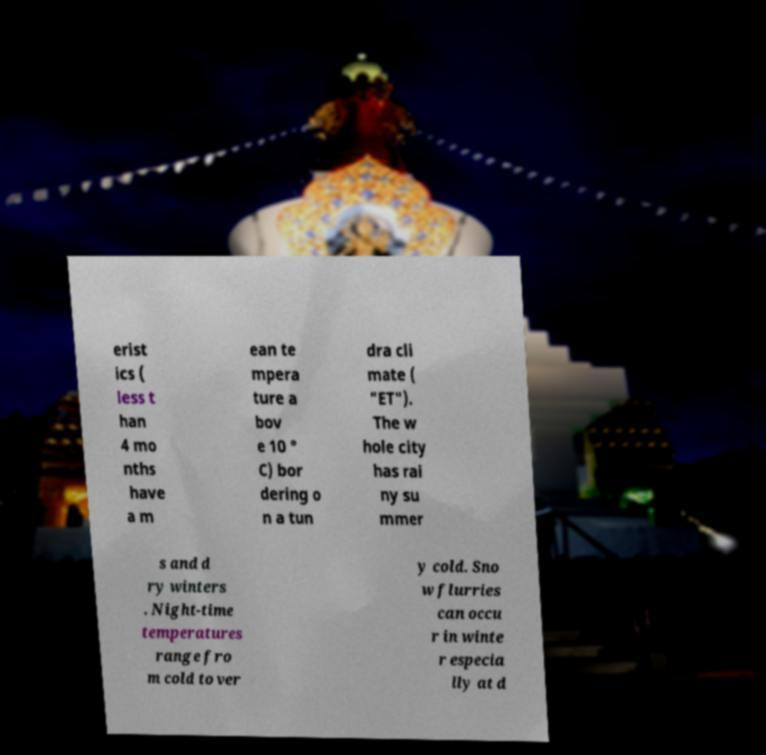Please read and relay the text visible in this image. What does it say? erist ics ( less t han 4 mo nths have a m ean te mpera ture a bov e 10 ° C) bor dering o n a tun dra cli mate ( "ET"). The w hole city has rai ny su mmer s and d ry winters . Night-time temperatures range fro m cold to ver y cold. Sno w flurries can occu r in winte r especia lly at d 